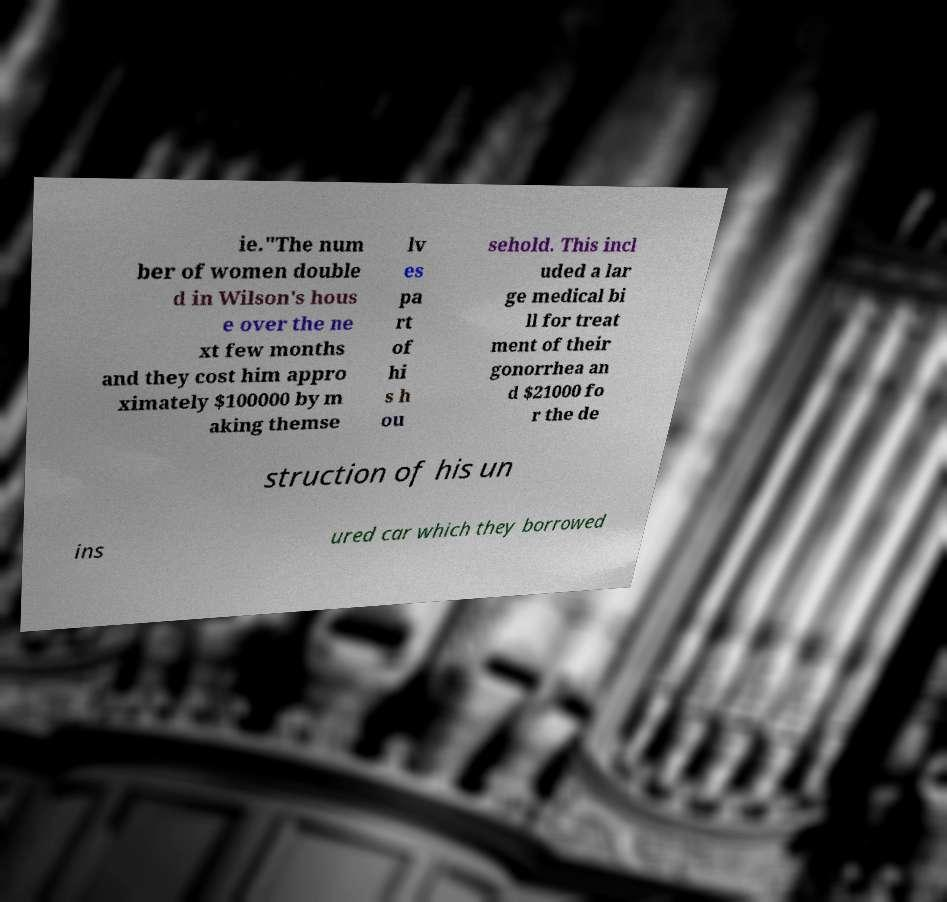For documentation purposes, I need the text within this image transcribed. Could you provide that? ie."The num ber of women double d in Wilson's hous e over the ne xt few months and they cost him appro ximately $100000 by m aking themse lv es pa rt of hi s h ou sehold. This incl uded a lar ge medical bi ll for treat ment of their gonorrhea an d $21000 fo r the de struction of his un ins ured car which they borrowed 